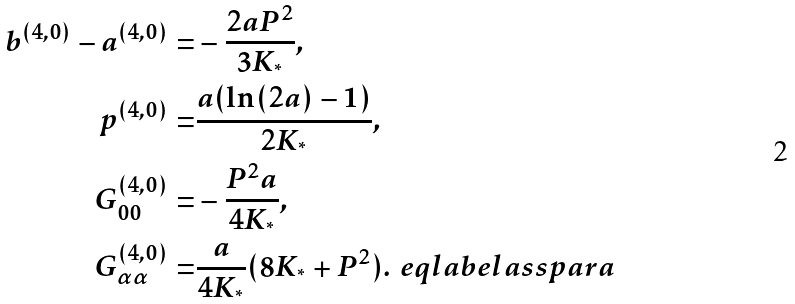Convert formula to latex. <formula><loc_0><loc_0><loc_500><loc_500>b ^ { ( 4 , 0 ) } - a ^ { ( 4 , 0 ) } = & - \frac { 2 a P ^ { 2 } } { 3 K _ { ^ { * } } } , \\ p ^ { ( 4 , 0 ) } = & \frac { a ( \ln ( 2 a ) - 1 ) } { 2 K _ { ^ { * } } } , \\ G _ { 0 0 } ^ { ( 4 , 0 ) } = & - \frac { P ^ { 2 } a } { 4 K _ { ^ { * } } } , \\ G _ { \alpha \alpha } ^ { ( 4 , 0 ) } = & \frac { a } { 4 K _ { ^ { * } } } ( 8 K _ { ^ { * } } + P ^ { 2 } ) . \ e q l a b e l { a s s p a r a }</formula> 